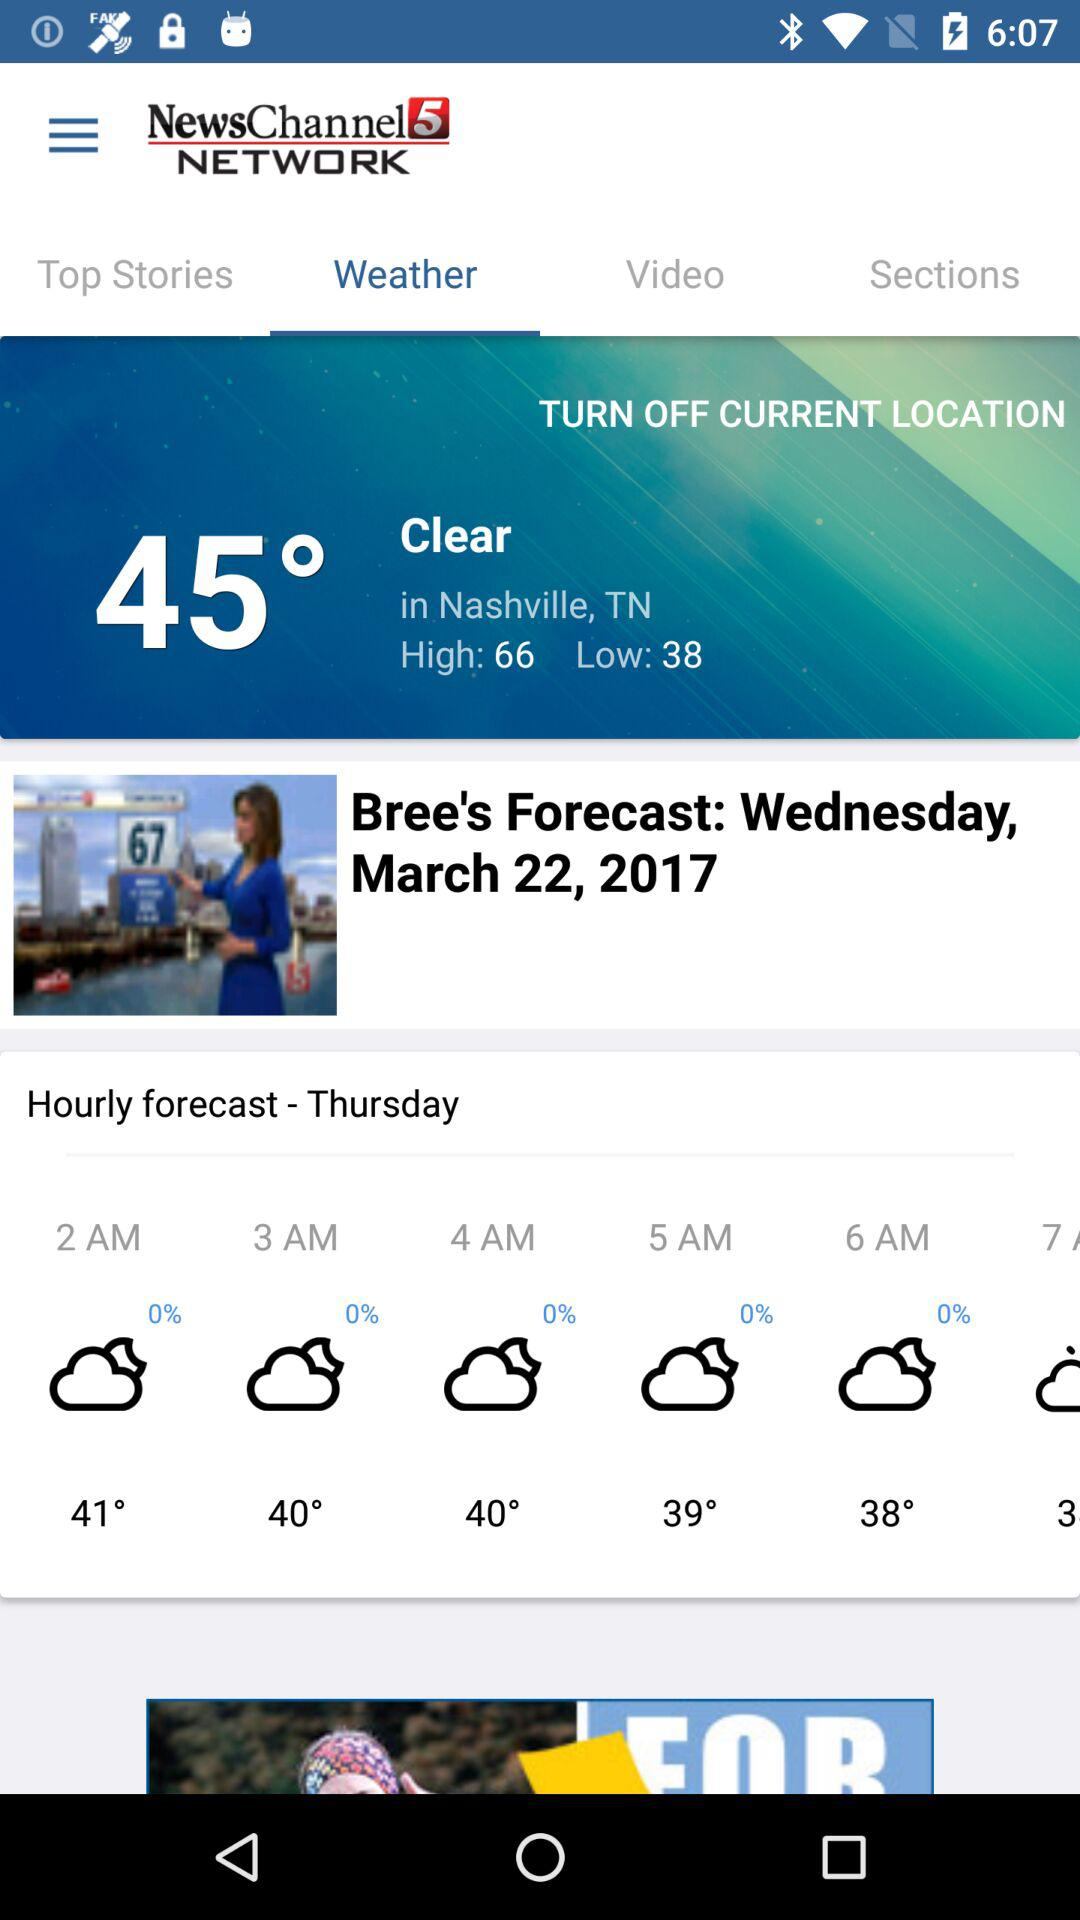What is the given date? The given date is Wednesday, March 22, 2017. 